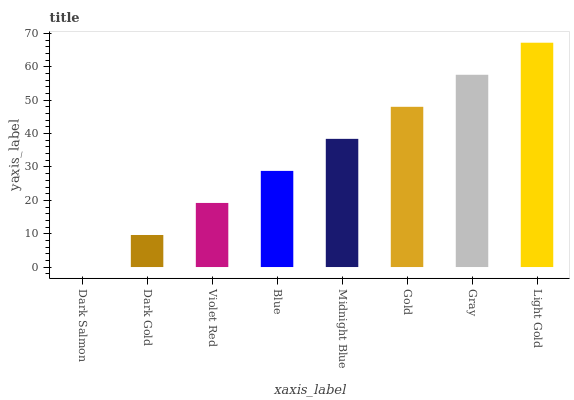Is Dark Salmon the minimum?
Answer yes or no. Yes. Is Light Gold the maximum?
Answer yes or no. Yes. Is Dark Gold the minimum?
Answer yes or no. No. Is Dark Gold the maximum?
Answer yes or no. No. Is Dark Gold greater than Dark Salmon?
Answer yes or no. Yes. Is Dark Salmon less than Dark Gold?
Answer yes or no. Yes. Is Dark Salmon greater than Dark Gold?
Answer yes or no. No. Is Dark Gold less than Dark Salmon?
Answer yes or no. No. Is Midnight Blue the high median?
Answer yes or no. Yes. Is Blue the low median?
Answer yes or no. Yes. Is Light Gold the high median?
Answer yes or no. No. Is Gold the low median?
Answer yes or no. No. 